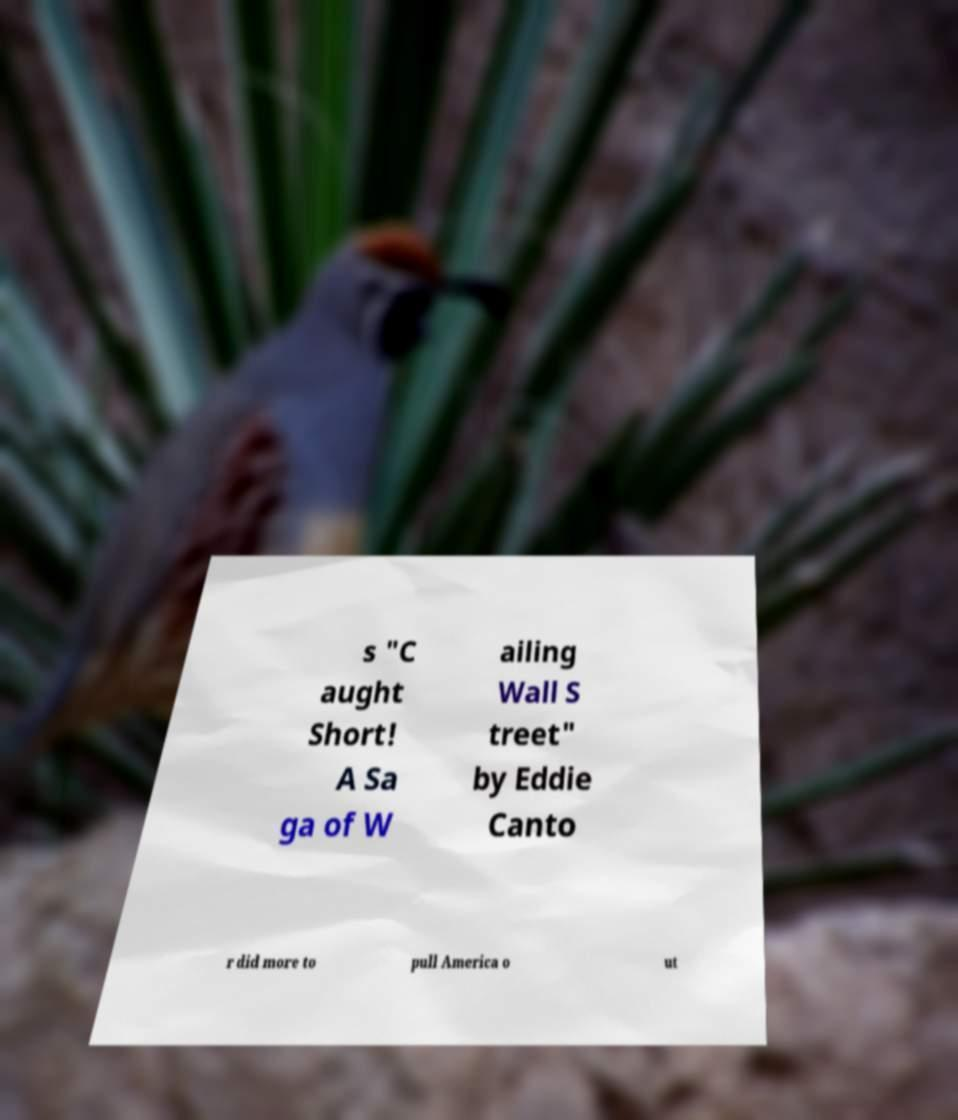I need the written content from this picture converted into text. Can you do that? s "C aught Short! A Sa ga of W ailing Wall S treet" by Eddie Canto r did more to pull America o ut 